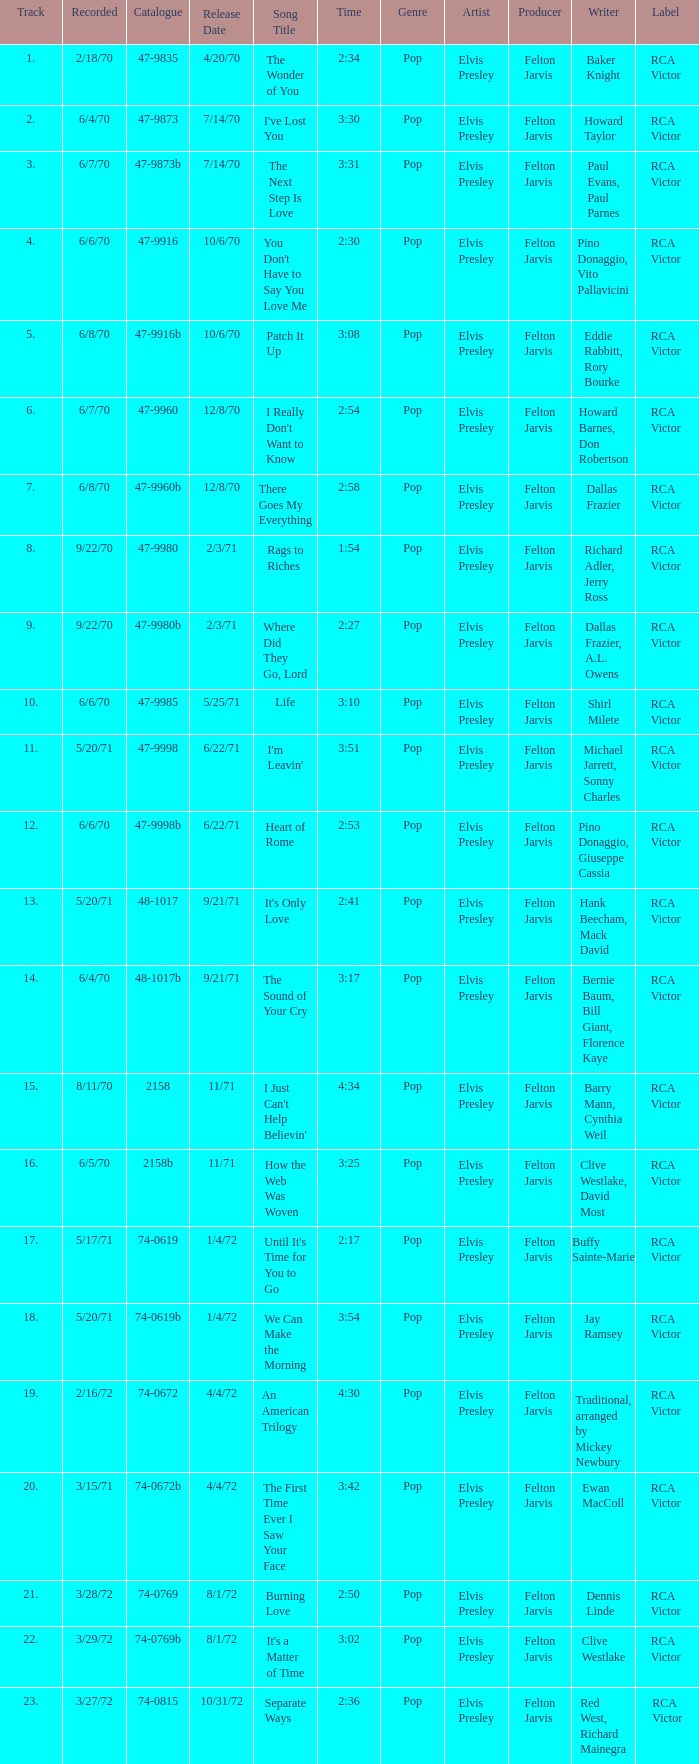What is the catalogue number for the song that is 3:17 and was released 9/21/71? 48-1017b. 